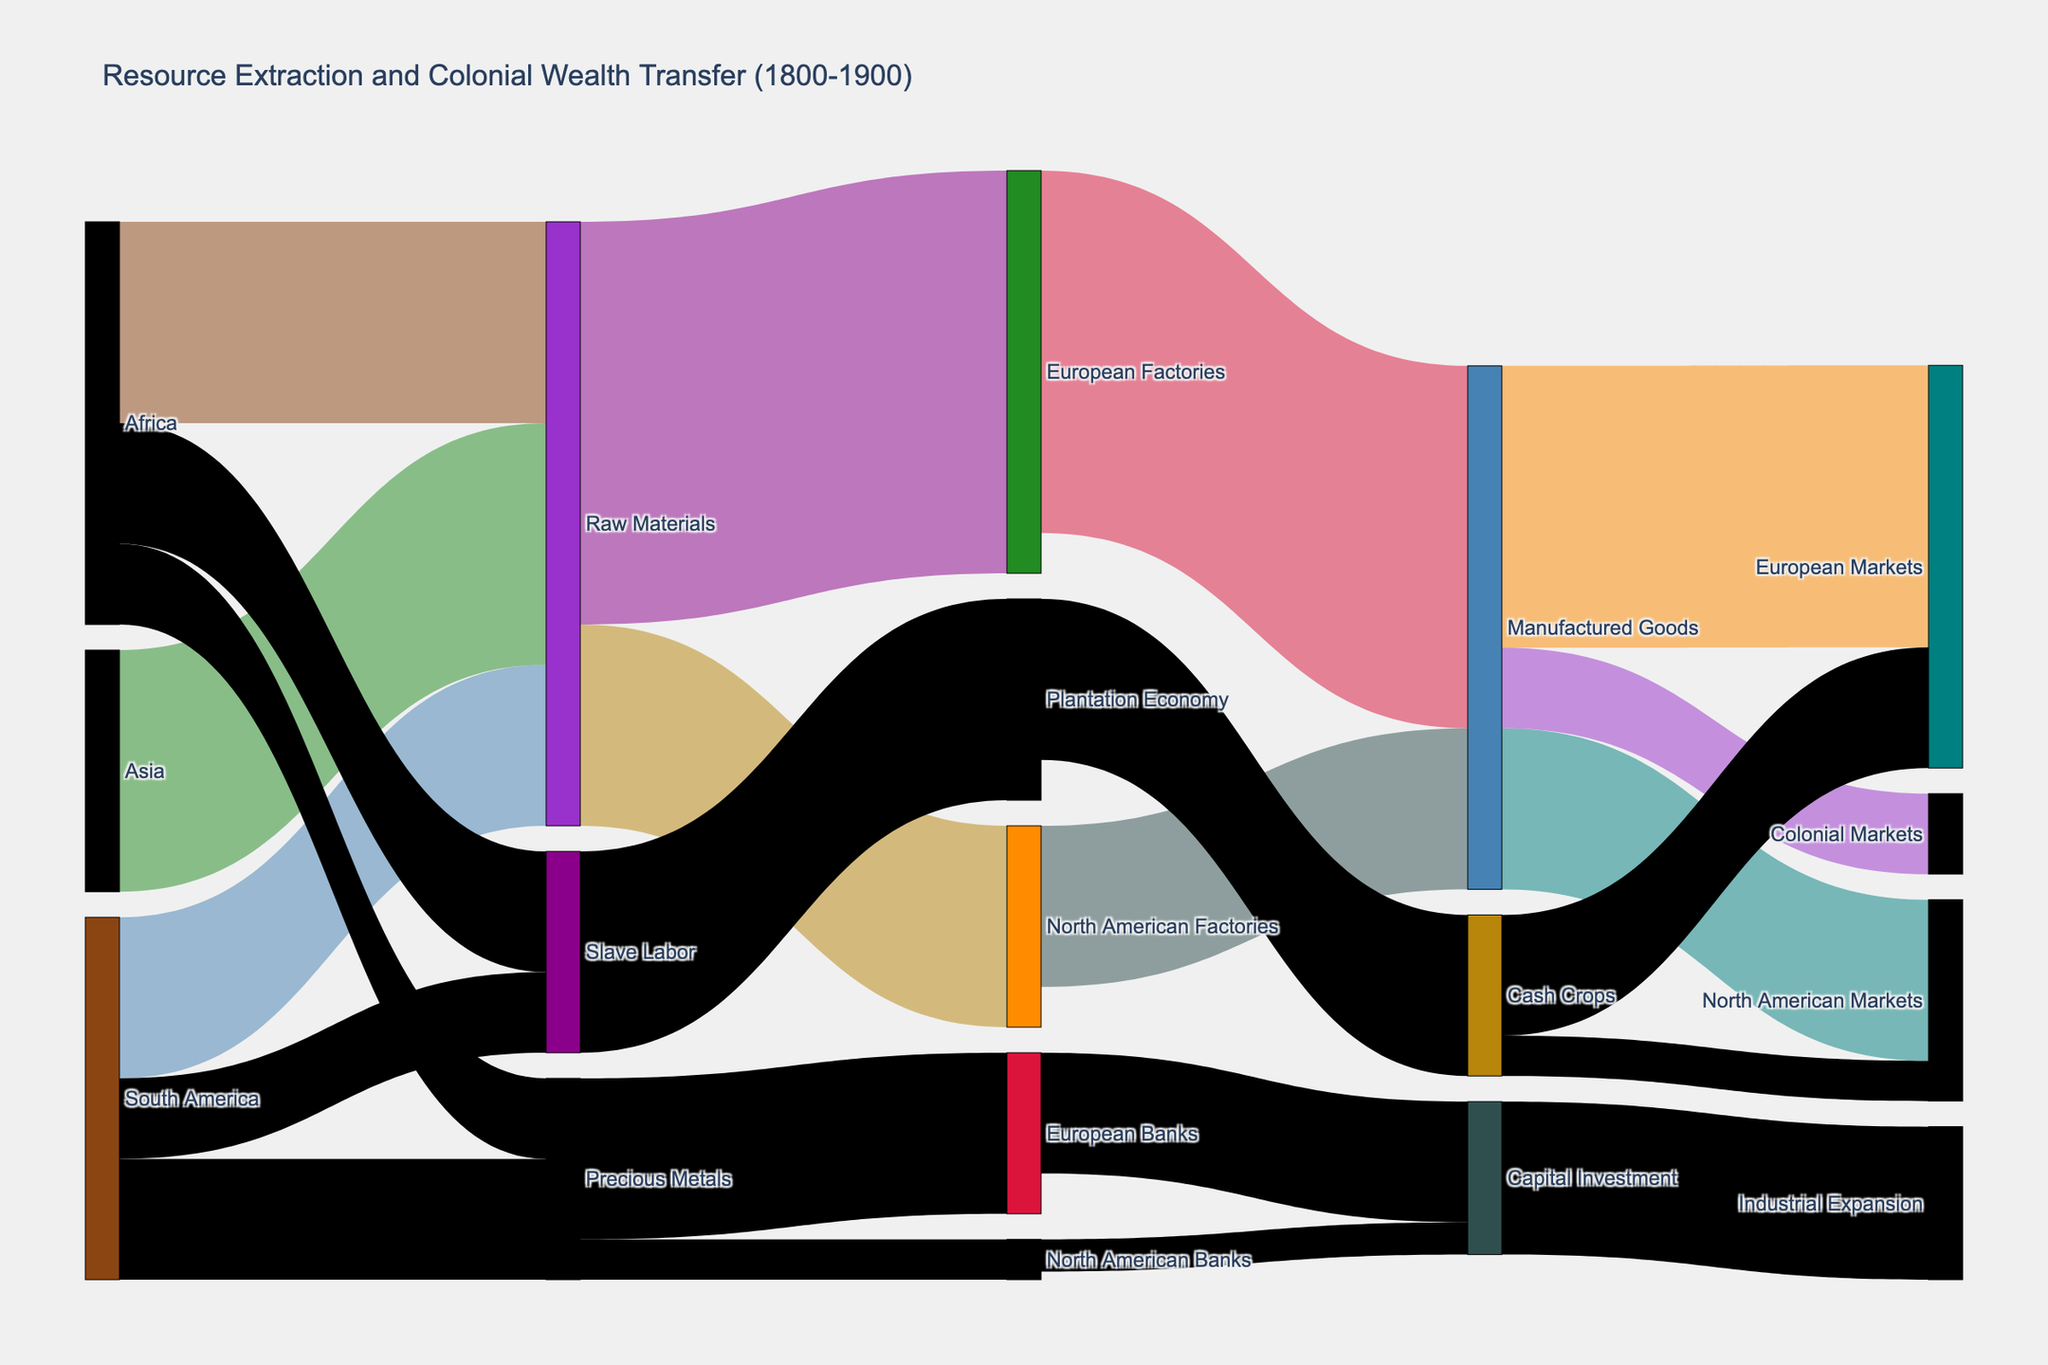Which region contributes the most raw materials to European and North American factories? First, look at the "Raw Materials" node to see which regions it connects to. The values between Africa, Asia, and South America must be summed. The highest contributing node is "Asia" with 300 units.
Answer: Asia What is the total value of manufactured goods produced by European and North American factories? Calculate the sum of values from "European Factories" and "North American Factories" to "Manufactured Goods." European Factories contribute 450 units and North American Factories 200 units, totaling 650 units.
Answer: 650 How much of the raw materials extracted from the Global South go to North American factories? Identify links from "Raw Materials" to "North American Factories" and note the value, which is 250 units.
Answer: 250 Which route does the least amount of manufactured goods flow through? Compare the flows from "Manufactured Goods" to "European Markets," "North American Markets," and "Colonial Markets." The smallest flow is to "Colonial Markets" with 100 units.
Answer: Colonial Markets Which regions provided slave labor, and what was the combined value? Identify the nodes connected to "Slave Labor." Both "Africa" and "South America" contribute, with 150 units from Africa and 100 units from South America, totaling 250 units.
Answer: Africa and South America, 250 What is the total value of precious metals extracted from Africa and South America combined? Check the values from "Africa" to "Precious Metals" and "South America" to "Precious Metals." Africa contributes 100 units, and South America contributes 150 units, totaling 250 units.
Answer: 250 Where does the majority of capital investment flow? Look at the "Capital Investment" node and follow the links. The majority of capital investment flows to "Industrial Expansion" with 190 units.
Answer: Industrial Expansion How much of the cash crops produced from the plantation economy are sent to North American markets? Identify the link from "Cash Crops" to "North American Markets" and note the value, which is 50 units.
Answer: 50 What's the total value transferred from precious metals to banks in Europe and North America combined? Check the values from "Precious Metals" to "European Banks" and "North American Banks." European Banks receive 200 units, and North American Banks receive 50 units, totaling 250 units.
Answer: 250 Compare the flows of raw materials sent to European factories versus North American factories. Which is greater and by how much? Identify the values flowing from "Raw Materials" to "European Factories" (500 units) and "North American Factories" (250 units). Europe's flow is greater by 250 units.
Answer: European factories, 250 units 